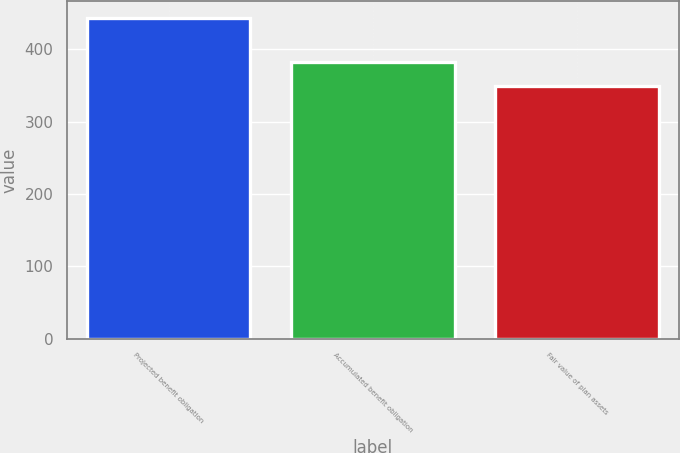Convert chart. <chart><loc_0><loc_0><loc_500><loc_500><bar_chart><fcel>Projected benefit obligation<fcel>Accumulated benefit obligation<fcel>Fair value of plan assets<nl><fcel>444<fcel>383<fcel>349<nl></chart> 